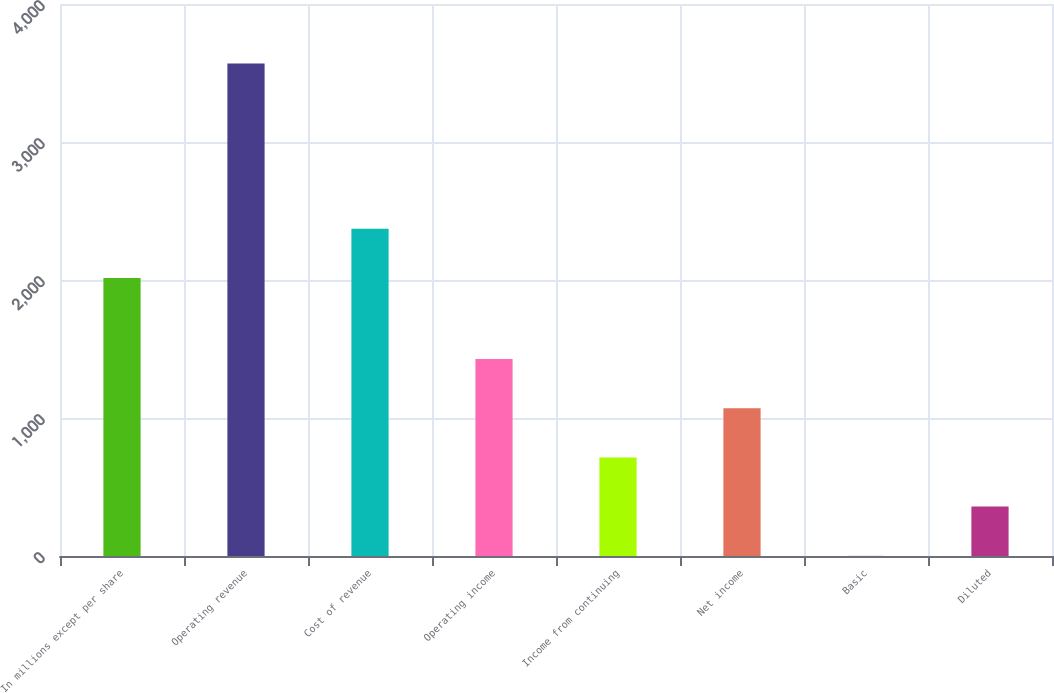Convert chart to OTSL. <chart><loc_0><loc_0><loc_500><loc_500><bar_chart><fcel>In millions except per share<fcel>Operating revenue<fcel>Cost of revenue<fcel>Operating income<fcel>Income from continuing<fcel>Net income<fcel>Basic<fcel>Diluted<nl><fcel>2014<fcel>3569<fcel>2370.8<fcel>1428.21<fcel>714.61<fcel>1071.41<fcel>1.01<fcel>357.81<nl></chart> 